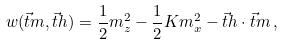<formula> <loc_0><loc_0><loc_500><loc_500>w ( \vec { t } { m } , \vec { t } { h } ) = \frac { 1 } { 2 } m _ { z } ^ { 2 } - \frac { 1 } { 2 } K m _ { x } ^ { 2 } - \vec { t } { h } \cdot \vec { t } { m } \, ,</formula> 